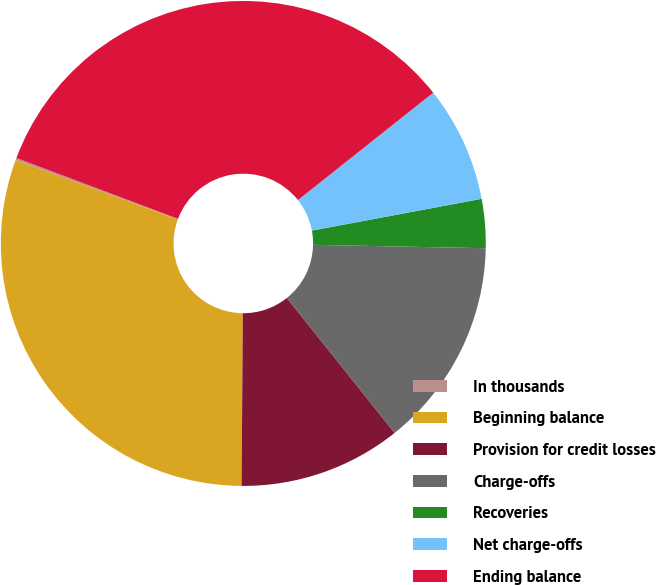Convert chart to OTSL. <chart><loc_0><loc_0><loc_500><loc_500><pie_chart><fcel>In thousands<fcel>Beginning balance<fcel>Provision for credit losses<fcel>Charge-offs<fcel>Recoveries<fcel>Net charge-offs<fcel>Ending balance<nl><fcel>0.14%<fcel>30.48%<fcel>10.84%<fcel>13.96%<fcel>3.26%<fcel>7.73%<fcel>33.59%<nl></chart> 